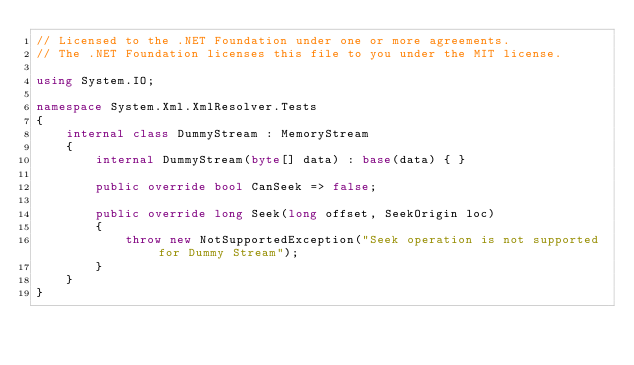<code> <loc_0><loc_0><loc_500><loc_500><_C#_>// Licensed to the .NET Foundation under one or more agreements.
// The .NET Foundation licenses this file to you under the MIT license.

using System.IO;

namespace System.Xml.XmlResolver.Tests
{
    internal class DummyStream : MemoryStream
    {
        internal DummyStream(byte[] data) : base(data) { }

        public override bool CanSeek => false;

        public override long Seek(long offset, SeekOrigin loc)
        {
            throw new NotSupportedException("Seek operation is not supported for Dummy Stream");
        }
    }
}
</code> 